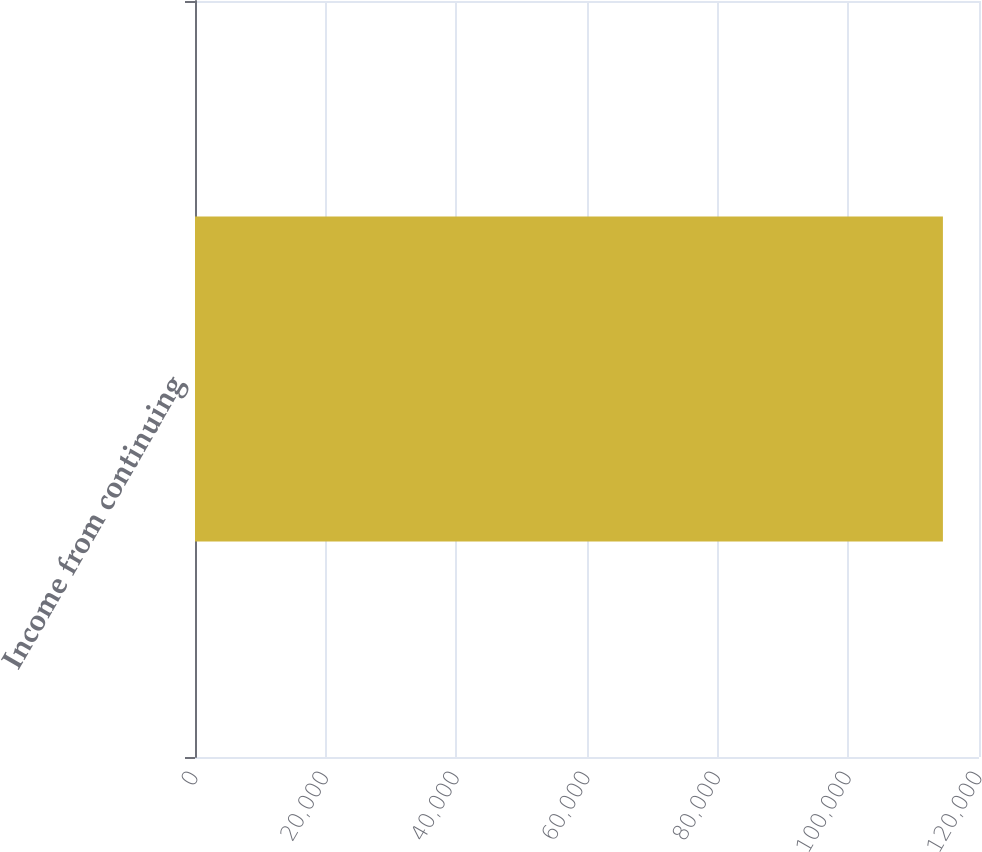Convert chart. <chart><loc_0><loc_0><loc_500><loc_500><bar_chart><fcel>Income from continuing<nl><fcel>114477<nl></chart> 